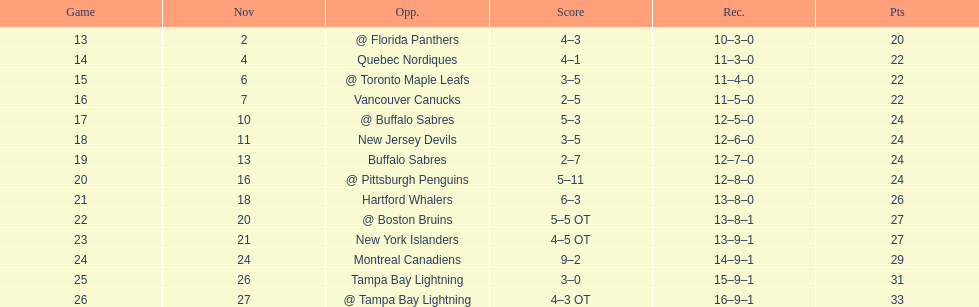Which was the only team in the atlantic division in the 1993-1994 season to acquire less points than the philadelphia flyers? Tampa Bay Lightning. 